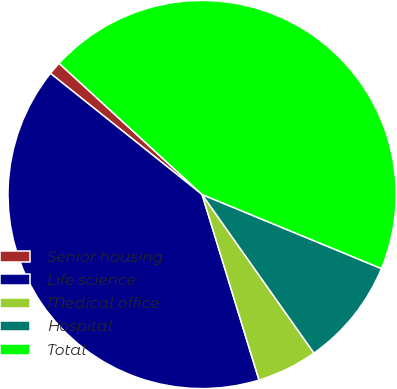<chart> <loc_0><loc_0><loc_500><loc_500><pie_chart><fcel>Senior housing<fcel>Life science<fcel>Medical office<fcel>Hospital<fcel>Total<nl><fcel>1.09%<fcel>40.47%<fcel>5.04%<fcel>8.99%<fcel>44.42%<nl></chart> 